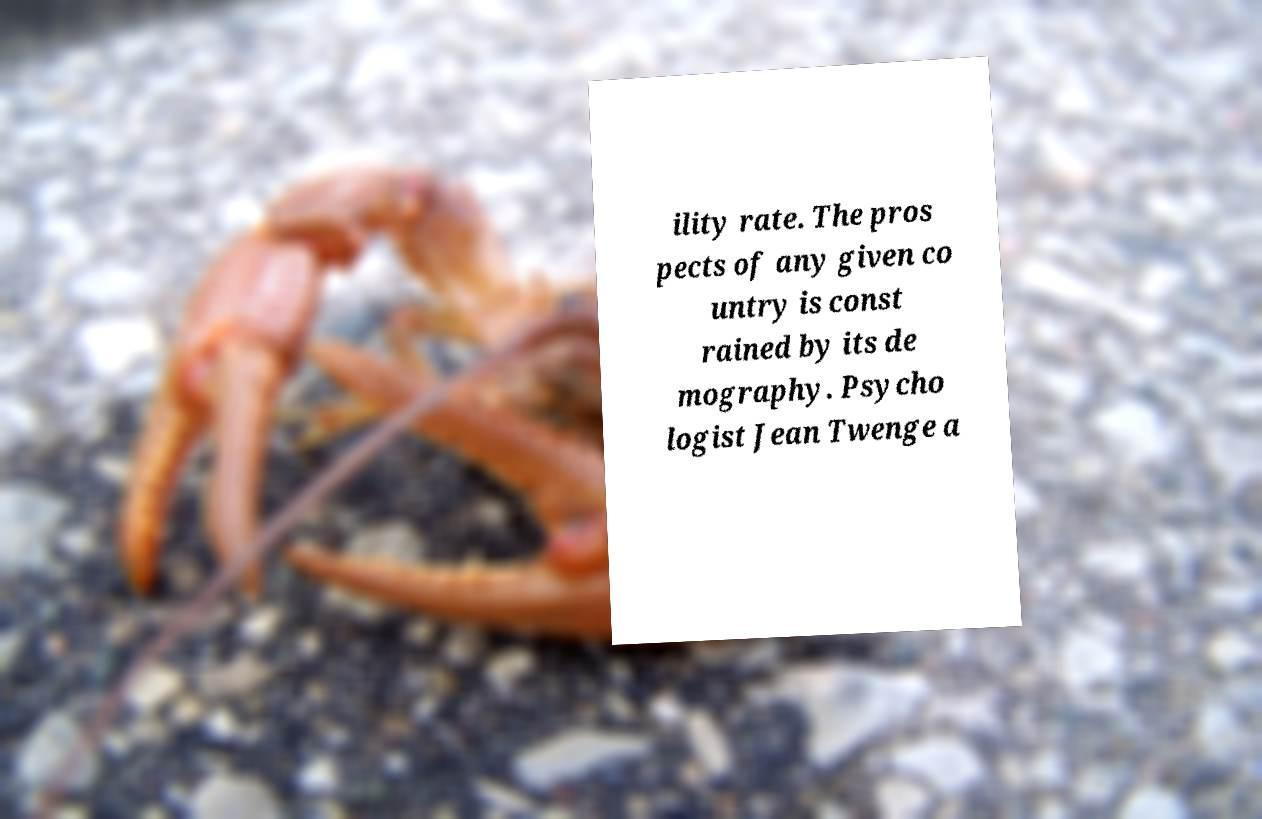There's text embedded in this image that I need extracted. Can you transcribe it verbatim? ility rate. The pros pects of any given co untry is const rained by its de mography. Psycho logist Jean Twenge a 